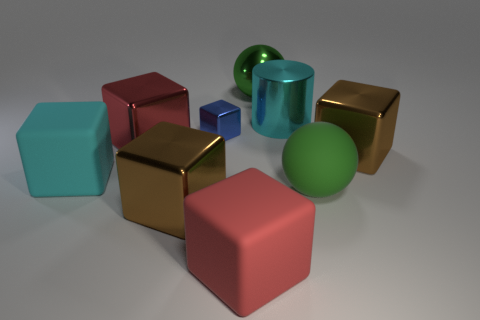Subtract all green balls. How many were subtracted if there are1green balls left? 1 Add 1 red matte cubes. How many objects exist? 10 Subtract all blue blocks. How many blocks are left? 5 Subtract all big blocks. How many blocks are left? 1 Subtract 5 cubes. How many cubes are left? 1 Subtract all red cylinders. Subtract all blue cubes. How many cylinders are left? 1 Subtract all cyan spheres. How many brown blocks are left? 2 Subtract all purple spheres. Subtract all small blue things. How many objects are left? 8 Add 1 green matte objects. How many green matte objects are left? 2 Add 9 green rubber spheres. How many green rubber spheres exist? 10 